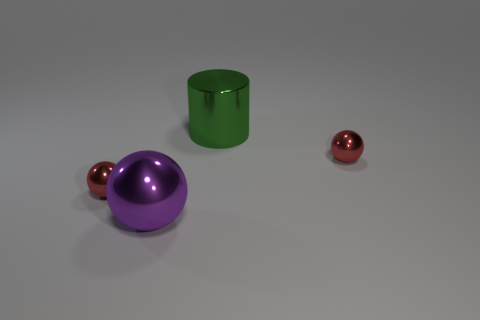The big purple object to the left of the large green object has what shape? The big purple object, situated to the left of the sizable green cylinder, exhibits a spherical shape. 